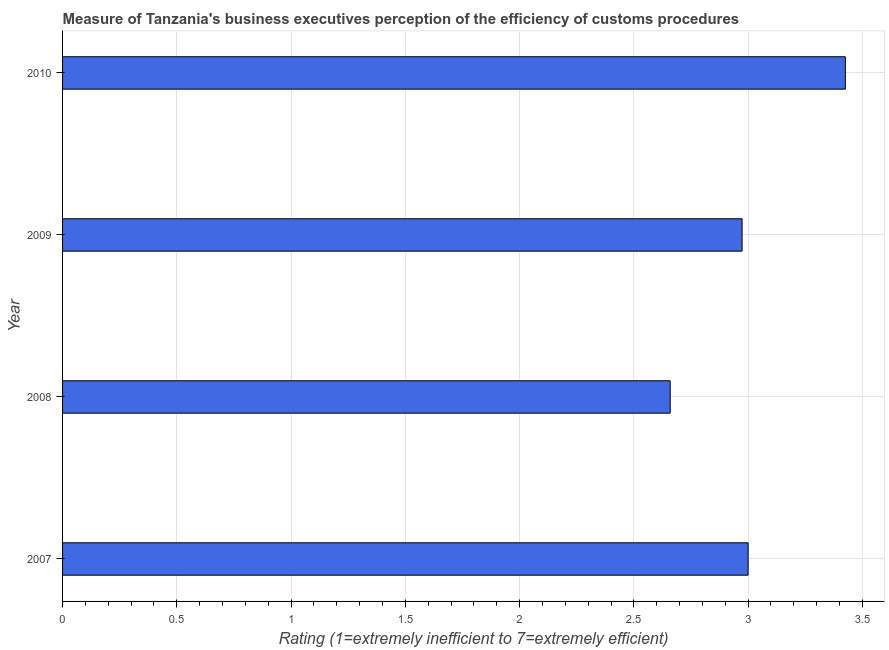Does the graph contain grids?
Provide a succinct answer. Yes. What is the title of the graph?
Make the answer very short. Measure of Tanzania's business executives perception of the efficiency of customs procedures. What is the label or title of the X-axis?
Your response must be concise. Rating (1=extremely inefficient to 7=extremely efficient). What is the label or title of the Y-axis?
Provide a short and direct response. Year. What is the rating measuring burden of customs procedure in 2008?
Ensure brevity in your answer.  2.66. Across all years, what is the maximum rating measuring burden of customs procedure?
Give a very brief answer. 3.43. Across all years, what is the minimum rating measuring burden of customs procedure?
Your response must be concise. 2.66. In which year was the rating measuring burden of customs procedure minimum?
Your response must be concise. 2008. What is the sum of the rating measuring burden of customs procedure?
Make the answer very short. 12.06. What is the difference between the rating measuring burden of customs procedure in 2008 and 2010?
Your answer should be very brief. -0.77. What is the average rating measuring burden of customs procedure per year?
Keep it short and to the point. 3.02. What is the median rating measuring burden of customs procedure?
Offer a very short reply. 2.99. In how many years, is the rating measuring burden of customs procedure greater than 0.5 ?
Your response must be concise. 4. What is the ratio of the rating measuring burden of customs procedure in 2008 to that in 2010?
Ensure brevity in your answer.  0.78. Is the rating measuring burden of customs procedure in 2007 less than that in 2010?
Offer a very short reply. Yes. What is the difference between the highest and the second highest rating measuring burden of customs procedure?
Your answer should be compact. 0.43. Is the sum of the rating measuring burden of customs procedure in 2007 and 2010 greater than the maximum rating measuring burden of customs procedure across all years?
Keep it short and to the point. Yes. What is the difference between the highest and the lowest rating measuring burden of customs procedure?
Offer a very short reply. 0.77. How many bars are there?
Keep it short and to the point. 4. How many years are there in the graph?
Make the answer very short. 4. What is the difference between two consecutive major ticks on the X-axis?
Give a very brief answer. 0.5. Are the values on the major ticks of X-axis written in scientific E-notation?
Offer a very short reply. No. What is the Rating (1=extremely inefficient to 7=extremely efficient) in 2007?
Keep it short and to the point. 3. What is the Rating (1=extremely inefficient to 7=extremely efficient) of 2008?
Your response must be concise. 2.66. What is the Rating (1=extremely inefficient to 7=extremely efficient) of 2009?
Provide a succinct answer. 2.97. What is the Rating (1=extremely inefficient to 7=extremely efficient) of 2010?
Give a very brief answer. 3.43. What is the difference between the Rating (1=extremely inefficient to 7=extremely efficient) in 2007 and 2008?
Your answer should be very brief. 0.34. What is the difference between the Rating (1=extremely inefficient to 7=extremely efficient) in 2007 and 2009?
Your response must be concise. 0.03. What is the difference between the Rating (1=extremely inefficient to 7=extremely efficient) in 2007 and 2010?
Provide a short and direct response. -0.43. What is the difference between the Rating (1=extremely inefficient to 7=extremely efficient) in 2008 and 2009?
Offer a terse response. -0.31. What is the difference between the Rating (1=extremely inefficient to 7=extremely efficient) in 2008 and 2010?
Your response must be concise. -0.77. What is the difference between the Rating (1=extremely inefficient to 7=extremely efficient) in 2009 and 2010?
Your answer should be very brief. -0.45. What is the ratio of the Rating (1=extremely inefficient to 7=extremely efficient) in 2007 to that in 2008?
Ensure brevity in your answer.  1.13. What is the ratio of the Rating (1=extremely inefficient to 7=extremely efficient) in 2007 to that in 2009?
Provide a succinct answer. 1.01. What is the ratio of the Rating (1=extremely inefficient to 7=extremely efficient) in 2007 to that in 2010?
Your response must be concise. 0.88. What is the ratio of the Rating (1=extremely inefficient to 7=extremely efficient) in 2008 to that in 2009?
Give a very brief answer. 0.89. What is the ratio of the Rating (1=extremely inefficient to 7=extremely efficient) in 2008 to that in 2010?
Offer a very short reply. 0.78. What is the ratio of the Rating (1=extremely inefficient to 7=extremely efficient) in 2009 to that in 2010?
Keep it short and to the point. 0.87. 